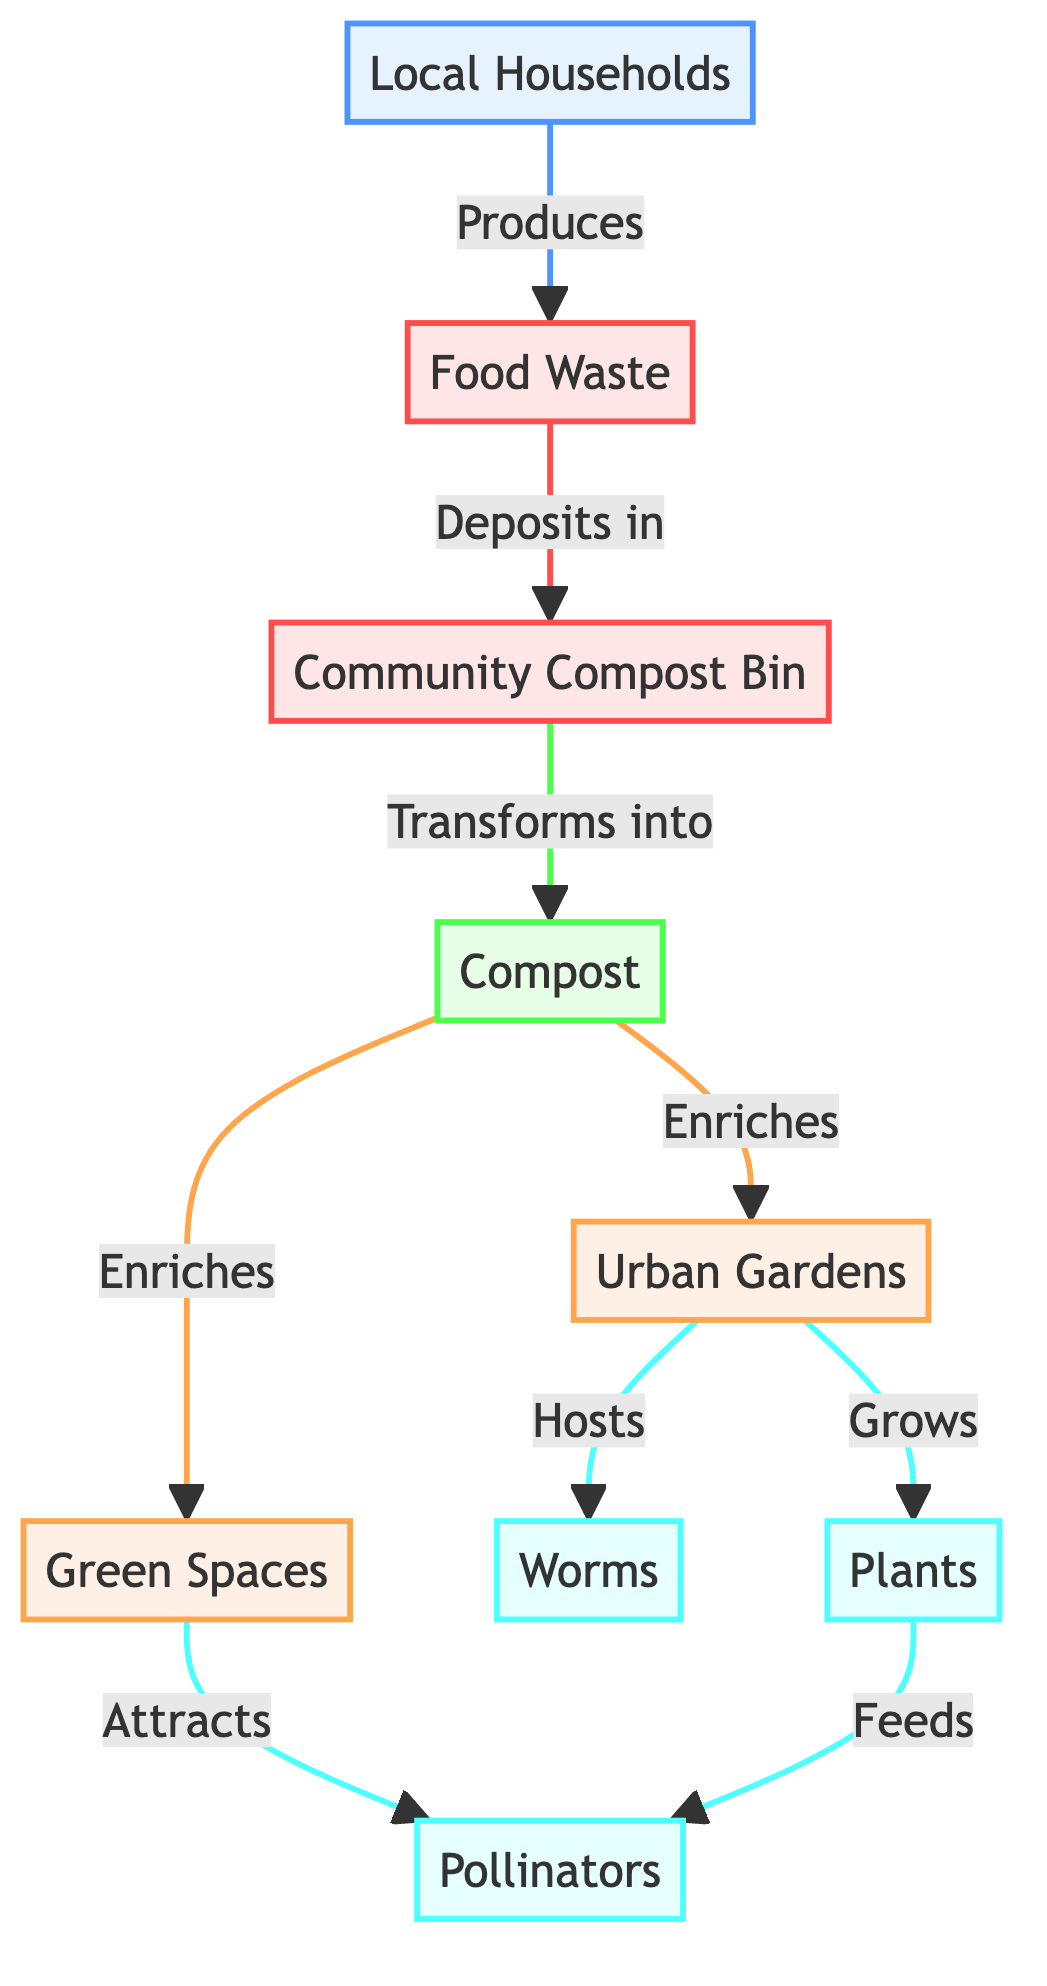What is the first node in the diagram? The first node is "Local Households," from where the flow begins in the diagram.
Answer: Local Households How many nodes represent garden spaces? There are two nodes that represent garden spaces: "Urban Gardens" and "Green Spaces."
Answer: 2 What do Local Households produce? Local Households produce "Food Waste," which is indicated as the output of the first node.
Answer: Food Waste What is created from the "Community Compost Bin"? "Compost" is produced from the "Community Compost Bin," as shown in the diagram.
Answer: Compost What do Urban Gardens attract? Urban Gardens attract "Worms" and "Plants," as illustrated by the relationships emanating from that node.
Answer: Worms and Plants What is the relationship between Compost and Urban Gardens? "Compost" enriches "Urban Gardens," indicating that compost improves the condition or productivity of these gardens.
Answer: Enriches How do Plants influence Pollinators? "Plants" feed "Pollinators," meaning that pollinators rely on plants for food, creating an important ecological relationship.
Answer: Feeds What is the output of food waste deposited in the Community Compost Bin? The output is "Compost," which is formed after the food waste undergoes a transformation process.
Answer: Compost Which two elements are supported by Compost? Compost supports both "Urban Gardens" and "Green Spaces," showing its dual role in the ecosystem.
Answer: Urban Gardens and Green Spaces How many types of organisms are involved in the ecosystem section? There are three types of organisms represented in the ecosystem section: "Worms," "Plants," and "Pollinators."
Answer: 3 